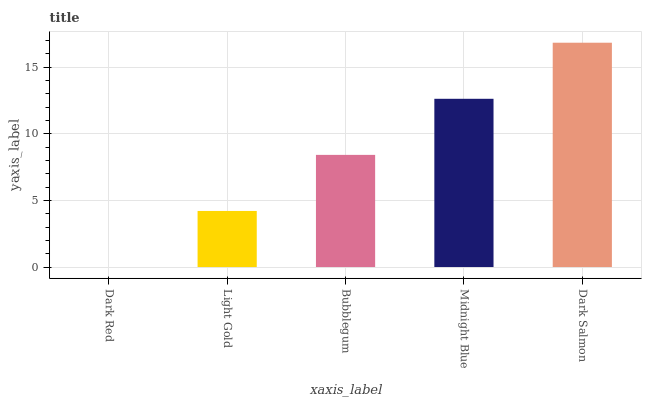Is Dark Red the minimum?
Answer yes or no. Yes. Is Dark Salmon the maximum?
Answer yes or no. Yes. Is Light Gold the minimum?
Answer yes or no. No. Is Light Gold the maximum?
Answer yes or no. No. Is Light Gold greater than Dark Red?
Answer yes or no. Yes. Is Dark Red less than Light Gold?
Answer yes or no. Yes. Is Dark Red greater than Light Gold?
Answer yes or no. No. Is Light Gold less than Dark Red?
Answer yes or no. No. Is Bubblegum the high median?
Answer yes or no. Yes. Is Bubblegum the low median?
Answer yes or no. Yes. Is Dark Salmon the high median?
Answer yes or no. No. Is Dark Red the low median?
Answer yes or no. No. 